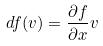<formula> <loc_0><loc_0><loc_500><loc_500>d f ( v ) = \frac { \partial f } { \partial x } v</formula> 